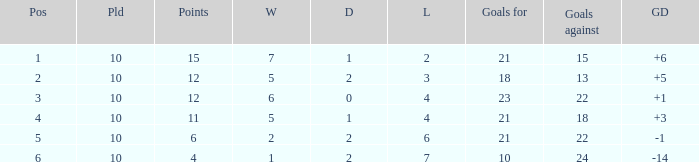Can you tell me the lowest Played that has the Position larger than 2, and the Draws smaller than 2, and the Goals against smaller than 18? None. 